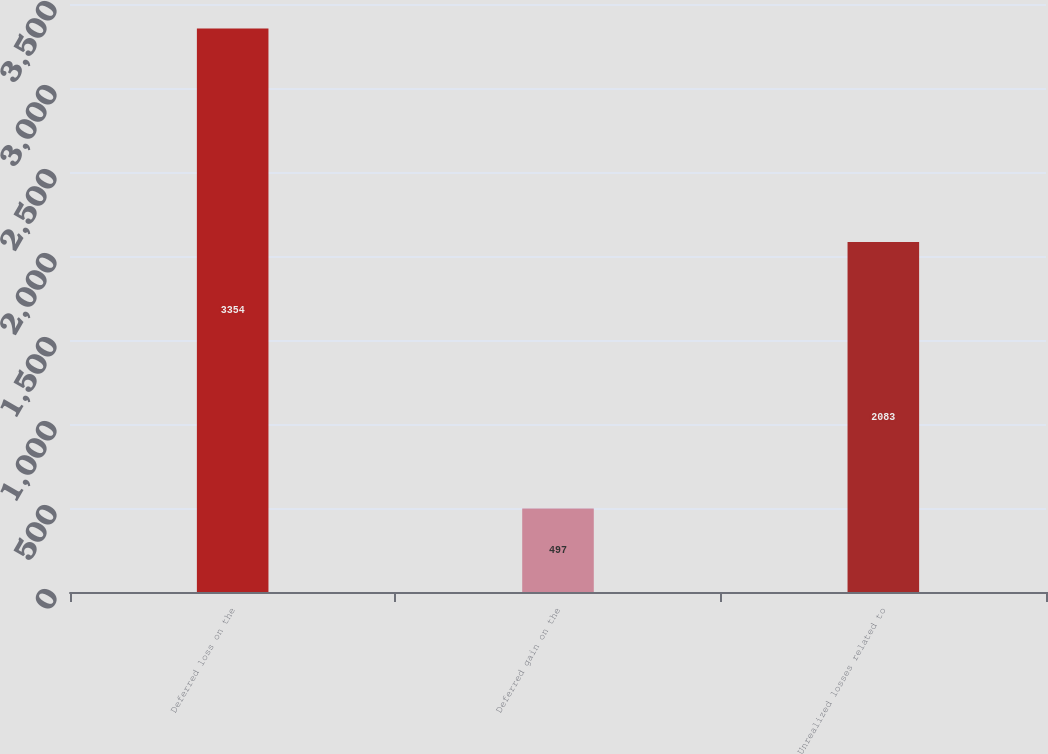Convert chart to OTSL. <chart><loc_0><loc_0><loc_500><loc_500><bar_chart><fcel>Deferred loss on the<fcel>Deferred gain on the<fcel>Unrealized losses related to<nl><fcel>3354<fcel>497<fcel>2083<nl></chart> 